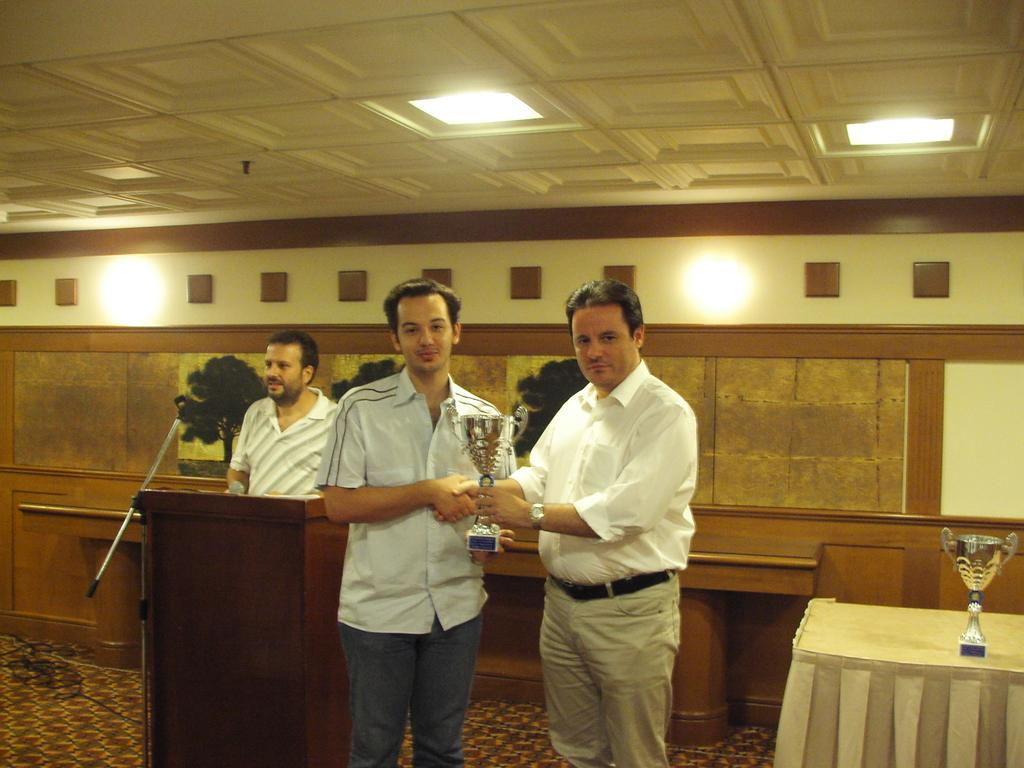What is happening in the image involving the man standing in the image? The man is giving a prize cup to another man. Can you describe the appearance of the man receiving the prize cup? The man receiving the prize cup is wearing a white color shirt. What can be seen on the left side of the image? There is another man standing near a podium on the left side of the image. What is visible at the top of the image? There are lights visible at the top of the image. What type of mist can be seen surrounding the structure in the image? There is no mist or structure present in the image. What color of yarn is being used by the man giving the prize cup? There is no yarn visible in the image; the man is giving a prize cup to another man. 